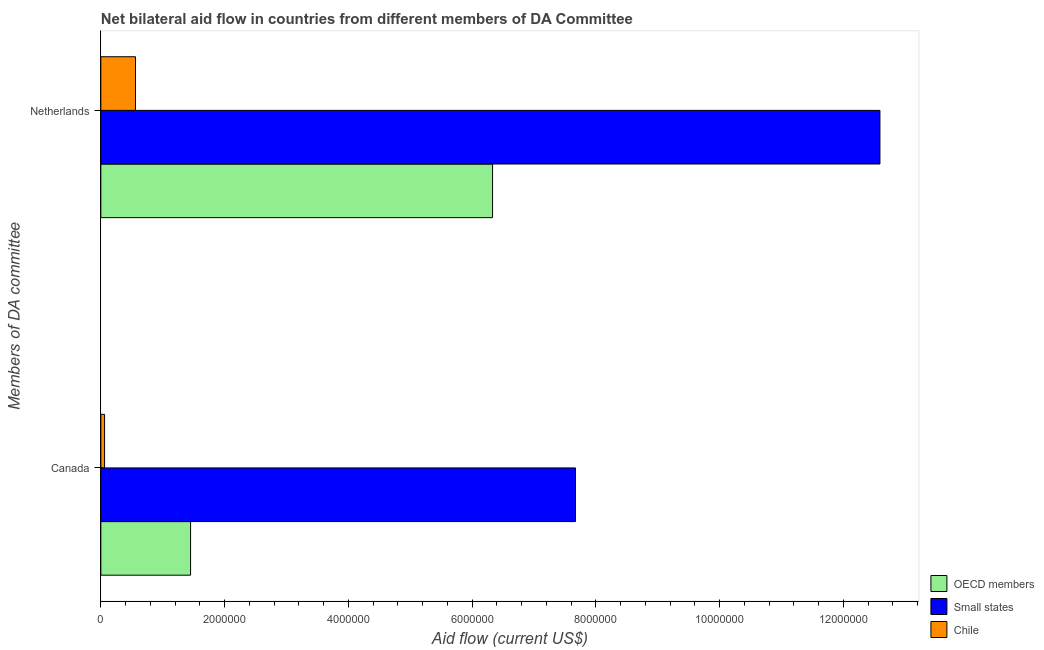Are the number of bars per tick equal to the number of legend labels?
Your answer should be compact. Yes. Are the number of bars on each tick of the Y-axis equal?
Provide a succinct answer. Yes. What is the amount of aid given by netherlands in OECD members?
Your answer should be compact. 6.33e+06. Across all countries, what is the maximum amount of aid given by netherlands?
Offer a very short reply. 1.26e+07. Across all countries, what is the minimum amount of aid given by netherlands?
Make the answer very short. 5.60e+05. In which country was the amount of aid given by netherlands maximum?
Provide a short and direct response. Small states. In which country was the amount of aid given by netherlands minimum?
Your answer should be compact. Chile. What is the total amount of aid given by canada in the graph?
Offer a very short reply. 9.18e+06. What is the difference between the amount of aid given by netherlands in Chile and that in OECD members?
Make the answer very short. -5.77e+06. What is the difference between the amount of aid given by netherlands in Small states and the amount of aid given by canada in OECD members?
Your response must be concise. 1.11e+07. What is the average amount of aid given by netherlands per country?
Your response must be concise. 6.49e+06. What is the difference between the amount of aid given by canada and amount of aid given by netherlands in OECD members?
Offer a terse response. -4.88e+06. In how many countries, is the amount of aid given by canada greater than 9600000 US$?
Your answer should be very brief. 0. What is the ratio of the amount of aid given by netherlands in Small states to that in Chile?
Offer a very short reply. 22.48. Is the amount of aid given by canada in Chile less than that in Small states?
Keep it short and to the point. Yes. In how many countries, is the amount of aid given by canada greater than the average amount of aid given by canada taken over all countries?
Your response must be concise. 1. What does the 3rd bar from the top in Netherlands represents?
Your answer should be very brief. OECD members. What does the 2nd bar from the bottom in Netherlands represents?
Ensure brevity in your answer.  Small states. How many bars are there?
Ensure brevity in your answer.  6. Are all the bars in the graph horizontal?
Your answer should be compact. Yes. How many countries are there in the graph?
Provide a succinct answer. 3. What is the difference between two consecutive major ticks on the X-axis?
Ensure brevity in your answer.  2.00e+06. Does the graph contain any zero values?
Your answer should be compact. No. Does the graph contain grids?
Provide a succinct answer. No. Where does the legend appear in the graph?
Give a very brief answer. Bottom right. What is the title of the graph?
Ensure brevity in your answer.  Net bilateral aid flow in countries from different members of DA Committee. Does "Hong Kong" appear as one of the legend labels in the graph?
Ensure brevity in your answer.  No. What is the label or title of the Y-axis?
Provide a short and direct response. Members of DA committee. What is the Aid flow (current US$) in OECD members in Canada?
Give a very brief answer. 1.45e+06. What is the Aid flow (current US$) of Small states in Canada?
Provide a succinct answer. 7.67e+06. What is the Aid flow (current US$) of OECD members in Netherlands?
Provide a short and direct response. 6.33e+06. What is the Aid flow (current US$) of Small states in Netherlands?
Your answer should be compact. 1.26e+07. What is the Aid flow (current US$) of Chile in Netherlands?
Your answer should be compact. 5.60e+05. Across all Members of DA committee, what is the maximum Aid flow (current US$) of OECD members?
Your answer should be compact. 6.33e+06. Across all Members of DA committee, what is the maximum Aid flow (current US$) of Small states?
Offer a terse response. 1.26e+07. Across all Members of DA committee, what is the maximum Aid flow (current US$) in Chile?
Ensure brevity in your answer.  5.60e+05. Across all Members of DA committee, what is the minimum Aid flow (current US$) of OECD members?
Offer a terse response. 1.45e+06. Across all Members of DA committee, what is the minimum Aid flow (current US$) in Small states?
Provide a short and direct response. 7.67e+06. What is the total Aid flow (current US$) in OECD members in the graph?
Make the answer very short. 7.78e+06. What is the total Aid flow (current US$) in Small states in the graph?
Give a very brief answer. 2.03e+07. What is the total Aid flow (current US$) in Chile in the graph?
Your response must be concise. 6.20e+05. What is the difference between the Aid flow (current US$) of OECD members in Canada and that in Netherlands?
Keep it short and to the point. -4.88e+06. What is the difference between the Aid flow (current US$) of Small states in Canada and that in Netherlands?
Your response must be concise. -4.92e+06. What is the difference between the Aid flow (current US$) of Chile in Canada and that in Netherlands?
Your answer should be compact. -5.00e+05. What is the difference between the Aid flow (current US$) of OECD members in Canada and the Aid flow (current US$) of Small states in Netherlands?
Provide a short and direct response. -1.11e+07. What is the difference between the Aid flow (current US$) of OECD members in Canada and the Aid flow (current US$) of Chile in Netherlands?
Offer a terse response. 8.90e+05. What is the difference between the Aid flow (current US$) in Small states in Canada and the Aid flow (current US$) in Chile in Netherlands?
Your answer should be very brief. 7.11e+06. What is the average Aid flow (current US$) of OECD members per Members of DA committee?
Keep it short and to the point. 3.89e+06. What is the average Aid flow (current US$) of Small states per Members of DA committee?
Your answer should be very brief. 1.01e+07. What is the average Aid flow (current US$) of Chile per Members of DA committee?
Make the answer very short. 3.10e+05. What is the difference between the Aid flow (current US$) of OECD members and Aid flow (current US$) of Small states in Canada?
Offer a very short reply. -6.22e+06. What is the difference between the Aid flow (current US$) of OECD members and Aid flow (current US$) of Chile in Canada?
Offer a very short reply. 1.39e+06. What is the difference between the Aid flow (current US$) of Small states and Aid flow (current US$) of Chile in Canada?
Your response must be concise. 7.61e+06. What is the difference between the Aid flow (current US$) of OECD members and Aid flow (current US$) of Small states in Netherlands?
Make the answer very short. -6.26e+06. What is the difference between the Aid flow (current US$) of OECD members and Aid flow (current US$) of Chile in Netherlands?
Provide a succinct answer. 5.77e+06. What is the difference between the Aid flow (current US$) of Small states and Aid flow (current US$) of Chile in Netherlands?
Your answer should be compact. 1.20e+07. What is the ratio of the Aid flow (current US$) in OECD members in Canada to that in Netherlands?
Keep it short and to the point. 0.23. What is the ratio of the Aid flow (current US$) of Small states in Canada to that in Netherlands?
Offer a very short reply. 0.61. What is the ratio of the Aid flow (current US$) of Chile in Canada to that in Netherlands?
Provide a succinct answer. 0.11. What is the difference between the highest and the second highest Aid flow (current US$) of OECD members?
Provide a short and direct response. 4.88e+06. What is the difference between the highest and the second highest Aid flow (current US$) of Small states?
Provide a short and direct response. 4.92e+06. What is the difference between the highest and the second highest Aid flow (current US$) of Chile?
Your answer should be very brief. 5.00e+05. What is the difference between the highest and the lowest Aid flow (current US$) of OECD members?
Offer a terse response. 4.88e+06. What is the difference between the highest and the lowest Aid flow (current US$) in Small states?
Make the answer very short. 4.92e+06. What is the difference between the highest and the lowest Aid flow (current US$) of Chile?
Offer a terse response. 5.00e+05. 